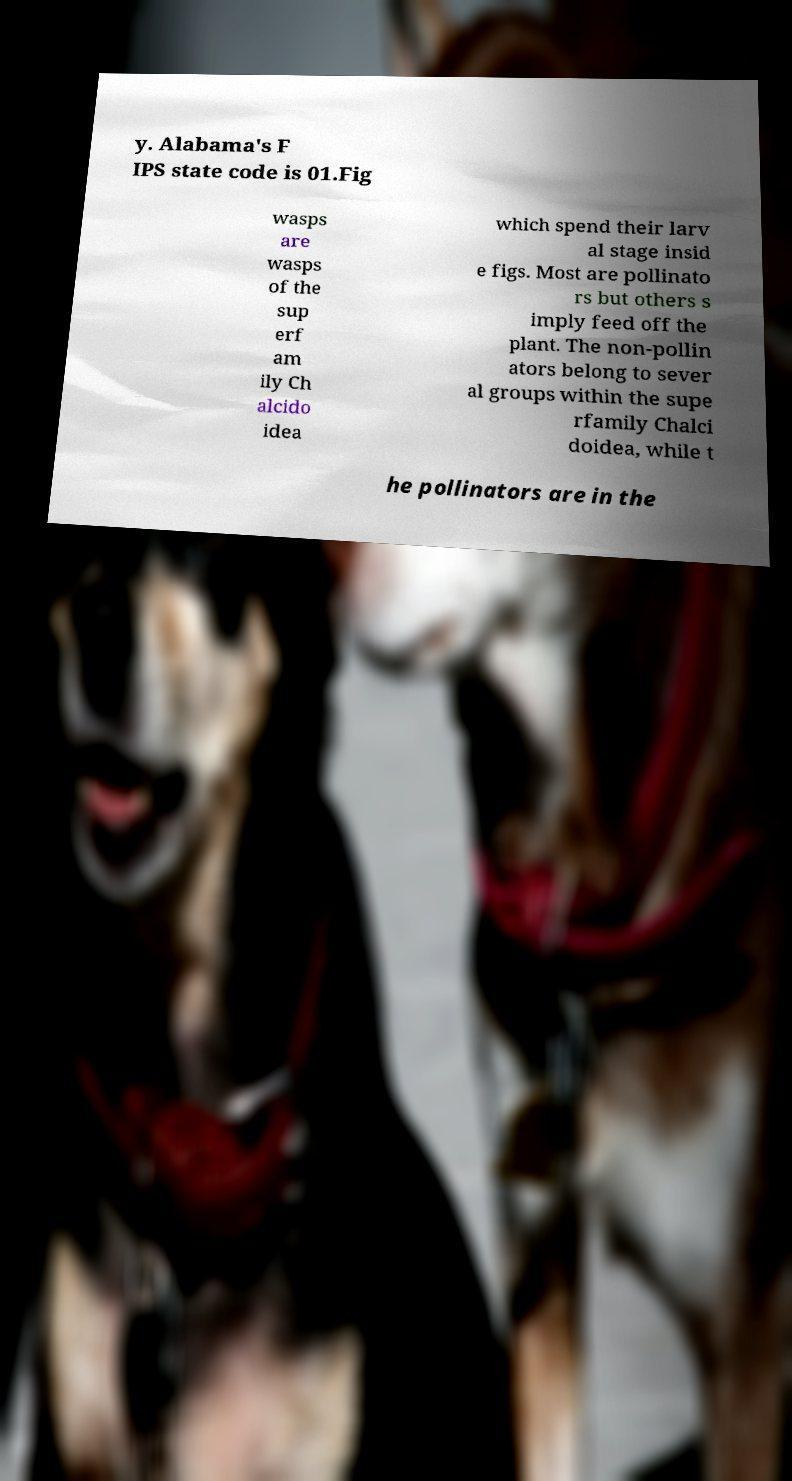Please read and relay the text visible in this image. What does it say? y. Alabama's F IPS state code is 01.Fig wasps are wasps of the sup erf am ily Ch alcido idea which spend their larv al stage insid e figs. Most are pollinato rs but others s imply feed off the plant. The non-pollin ators belong to sever al groups within the supe rfamily Chalci doidea, while t he pollinators are in the 